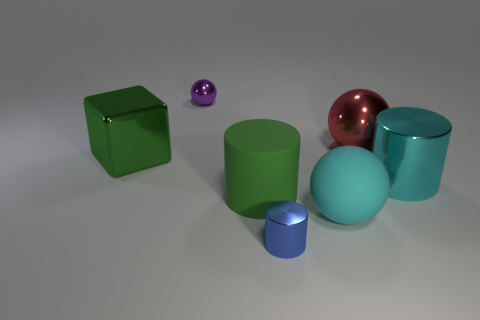There is a large object that is the same color as the block; what material is it?
Make the answer very short. Rubber. What is the shape of the green thing that is behind the large green matte cylinder?
Offer a very short reply. Cube. What number of red metal balls are there?
Your answer should be very brief. 1. What color is the large cylinder that is the same material as the cyan ball?
Offer a terse response. Green. How many small objects are either brown spheres or red objects?
Your answer should be compact. 0. There is a red metallic object; what number of cyan objects are left of it?
Your response must be concise. 1. The other big metal object that is the same shape as the purple thing is what color?
Your answer should be compact. Red. How many metallic objects are either blue cylinders or large cylinders?
Offer a terse response. 2. Is there a small metal ball to the right of the shiny ball that is behind the red sphere right of the cyan ball?
Make the answer very short. No. What is the color of the cube?
Ensure brevity in your answer.  Green. 